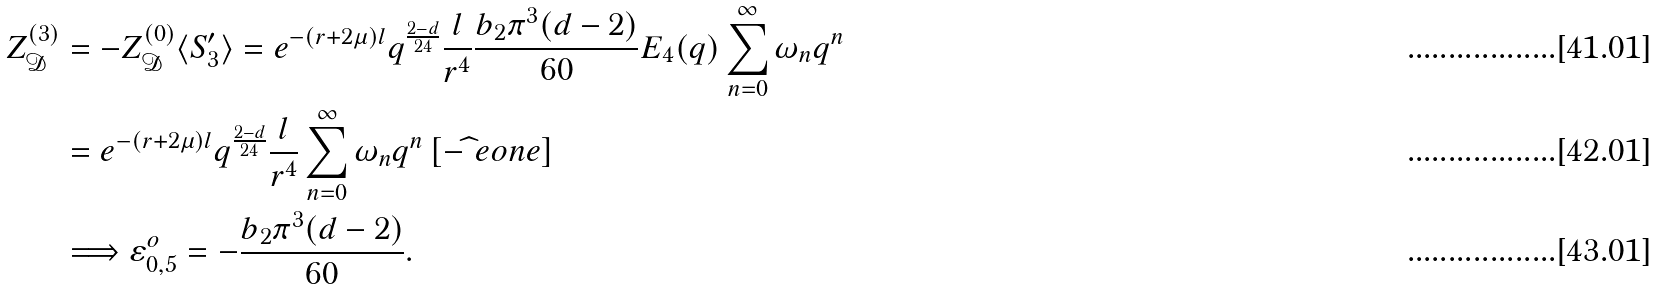<formula> <loc_0><loc_0><loc_500><loc_500>Z _ { \mathcal { D } } ^ { ( 3 ) } & = - Z _ { \mathcal { D } } ^ { ( 0 ) } \langle S ^ { \prime } _ { 3 } \rangle = e ^ { - ( r + 2 \mu ) l } q ^ { \frac { 2 - d } { 2 4 } } \frac { l } { r ^ { 4 } } \frac { b _ { 2 } \pi ^ { 3 } ( d - 2 ) } { 6 0 } E _ { 4 } ( q ) \sum _ { n = 0 } ^ { \infty } \omega _ { n } q ^ { n } \\ & = e ^ { - ( r + 2 \mu ) l } q ^ { \frac { 2 - d } { 2 4 } } \frac { l } { r ^ { 4 } } \sum _ { n = 0 } ^ { \infty } \omega _ { n } q ^ { n } \left [ - \widehat { \ } e o n e \right ] \\ & \Longrightarrow \varepsilon ^ { o } _ { 0 , 5 } = - \frac { b _ { 2 } \pi ^ { 3 } ( d - 2 ) } { 6 0 } .</formula> 